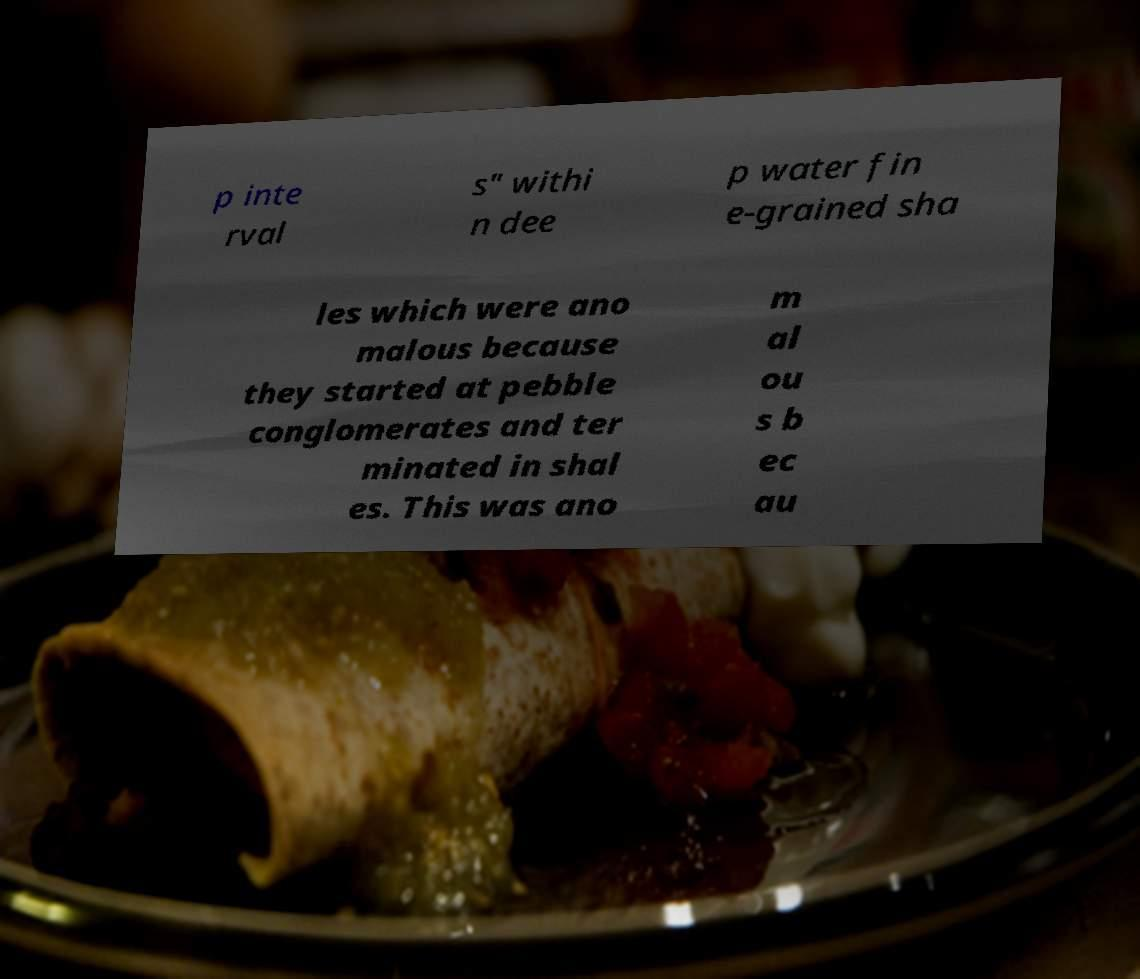There's text embedded in this image that I need extracted. Can you transcribe it verbatim? p inte rval s" withi n dee p water fin e-grained sha les which were ano malous because they started at pebble conglomerates and ter minated in shal es. This was ano m al ou s b ec au 